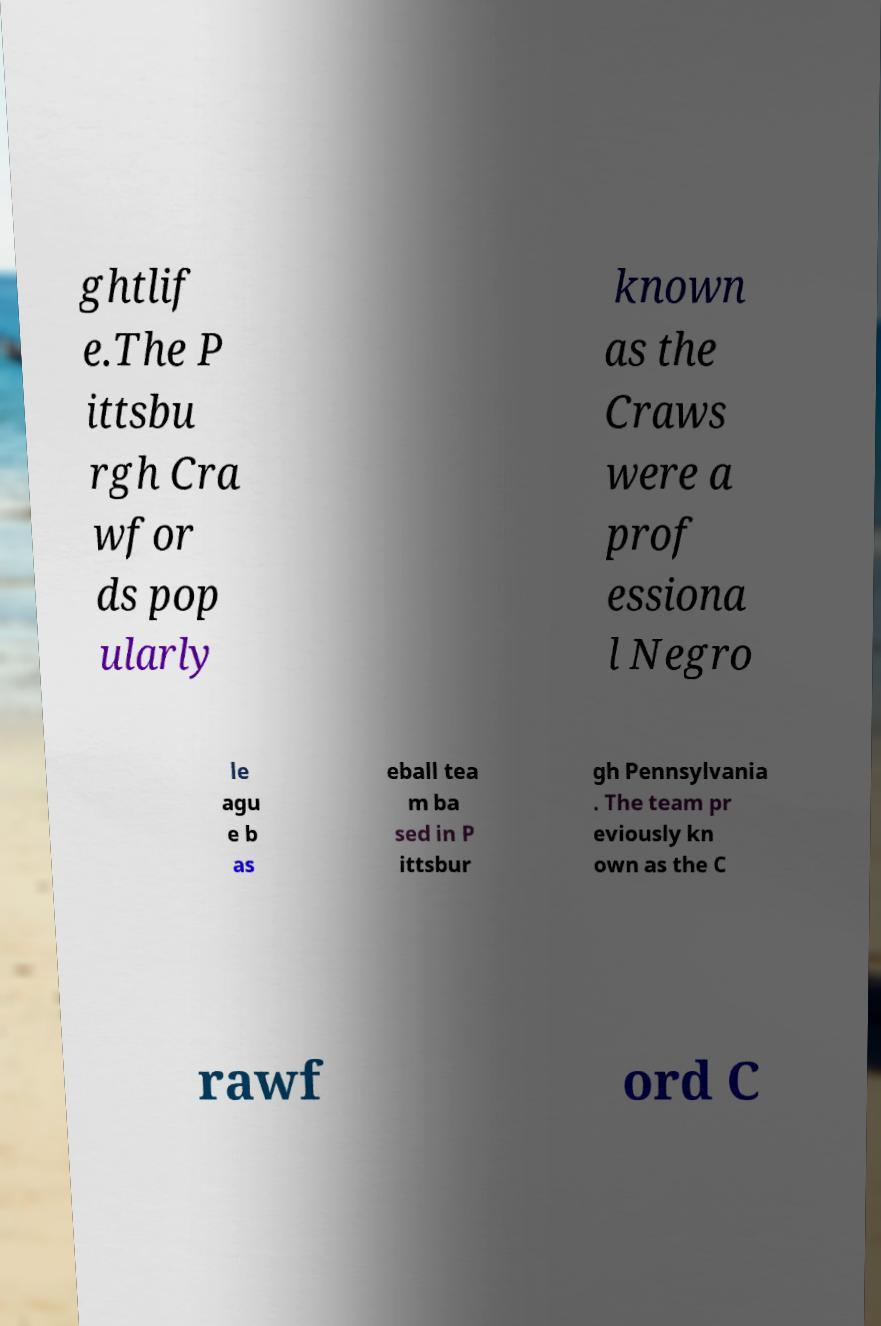I need the written content from this picture converted into text. Can you do that? ghtlif e.The P ittsbu rgh Cra wfor ds pop ularly known as the Craws were a prof essiona l Negro le agu e b as eball tea m ba sed in P ittsbur gh Pennsylvania . The team pr eviously kn own as the C rawf ord C 